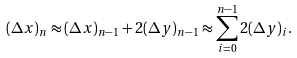<formula> <loc_0><loc_0><loc_500><loc_500>( \Delta x ) _ { n } \approx ( \Delta x ) _ { n - 1 } + 2 ( \Delta y ) _ { n - 1 } \approx \sum _ { i = 0 } ^ { n - 1 } 2 ( \Delta y ) _ { i } .</formula> 